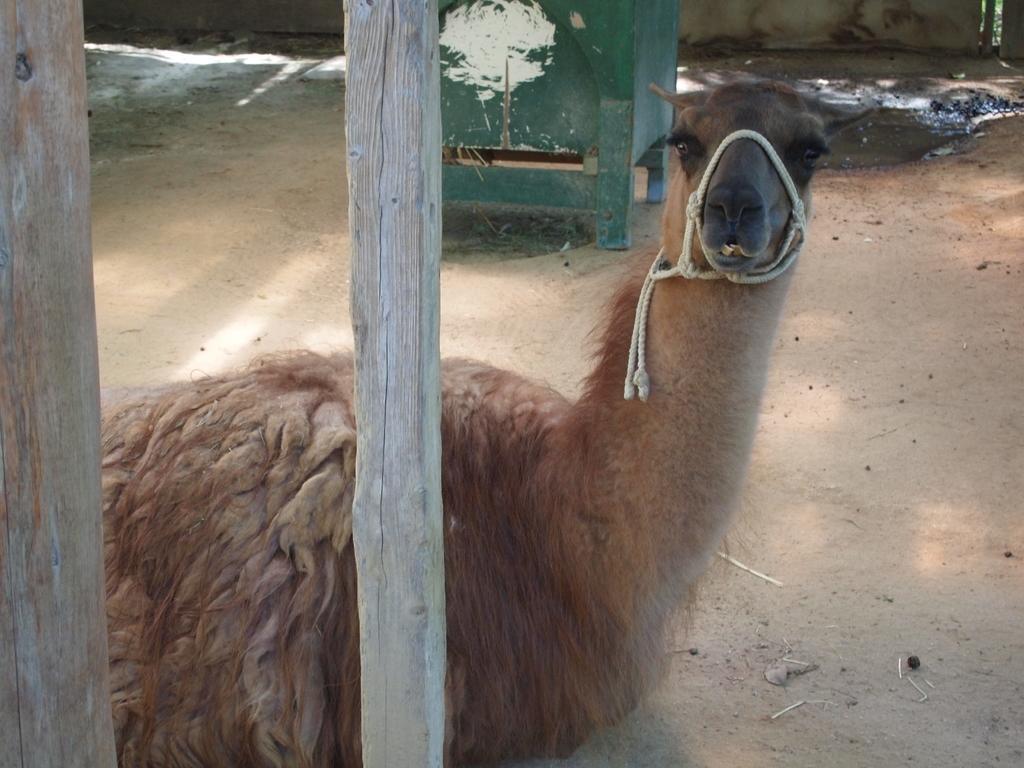Describe this image in one or two sentences. In this image we can see a camel sitting on the ground, in front of it there are two wooden sticks, and behind the camel we can see an objects. 